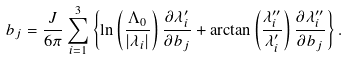<formula> <loc_0><loc_0><loc_500><loc_500>b _ { j } = \frac { J } { 6 \pi } \sum _ { i = 1 } ^ { 3 } \left \{ \ln \left ( \frac { \Lambda _ { 0 } } { | \lambda _ { i } | } \right ) \frac { \partial \lambda ^ { \prime } _ { i } } { \partial b _ { j } } + \arctan \left ( \frac { \lambda ^ { \prime \prime } _ { i } } { \lambda ^ { \prime } _ { i } } \right ) \frac { \partial \lambda ^ { \prime \prime } _ { i } } { \partial b _ { j } } \right \} .</formula> 